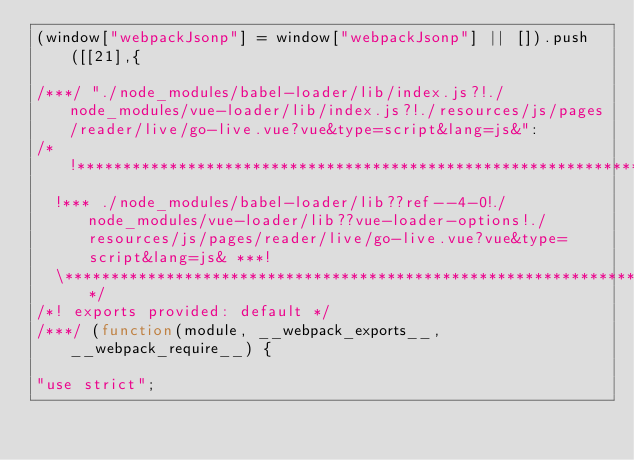<code> <loc_0><loc_0><loc_500><loc_500><_JavaScript_>(window["webpackJsonp"] = window["webpackJsonp"] || []).push([[21],{

/***/ "./node_modules/babel-loader/lib/index.js?!./node_modules/vue-loader/lib/index.js?!./resources/js/pages/reader/live/go-live.vue?vue&type=script&lang=js&":
/*!*************************************************************************************************************************************************************************!*\
  !*** ./node_modules/babel-loader/lib??ref--4-0!./node_modules/vue-loader/lib??vue-loader-options!./resources/js/pages/reader/live/go-live.vue?vue&type=script&lang=js& ***!
  \*************************************************************************************************************************************************************************/
/*! exports provided: default */
/***/ (function(module, __webpack_exports__, __webpack_require__) {

"use strict";</code> 